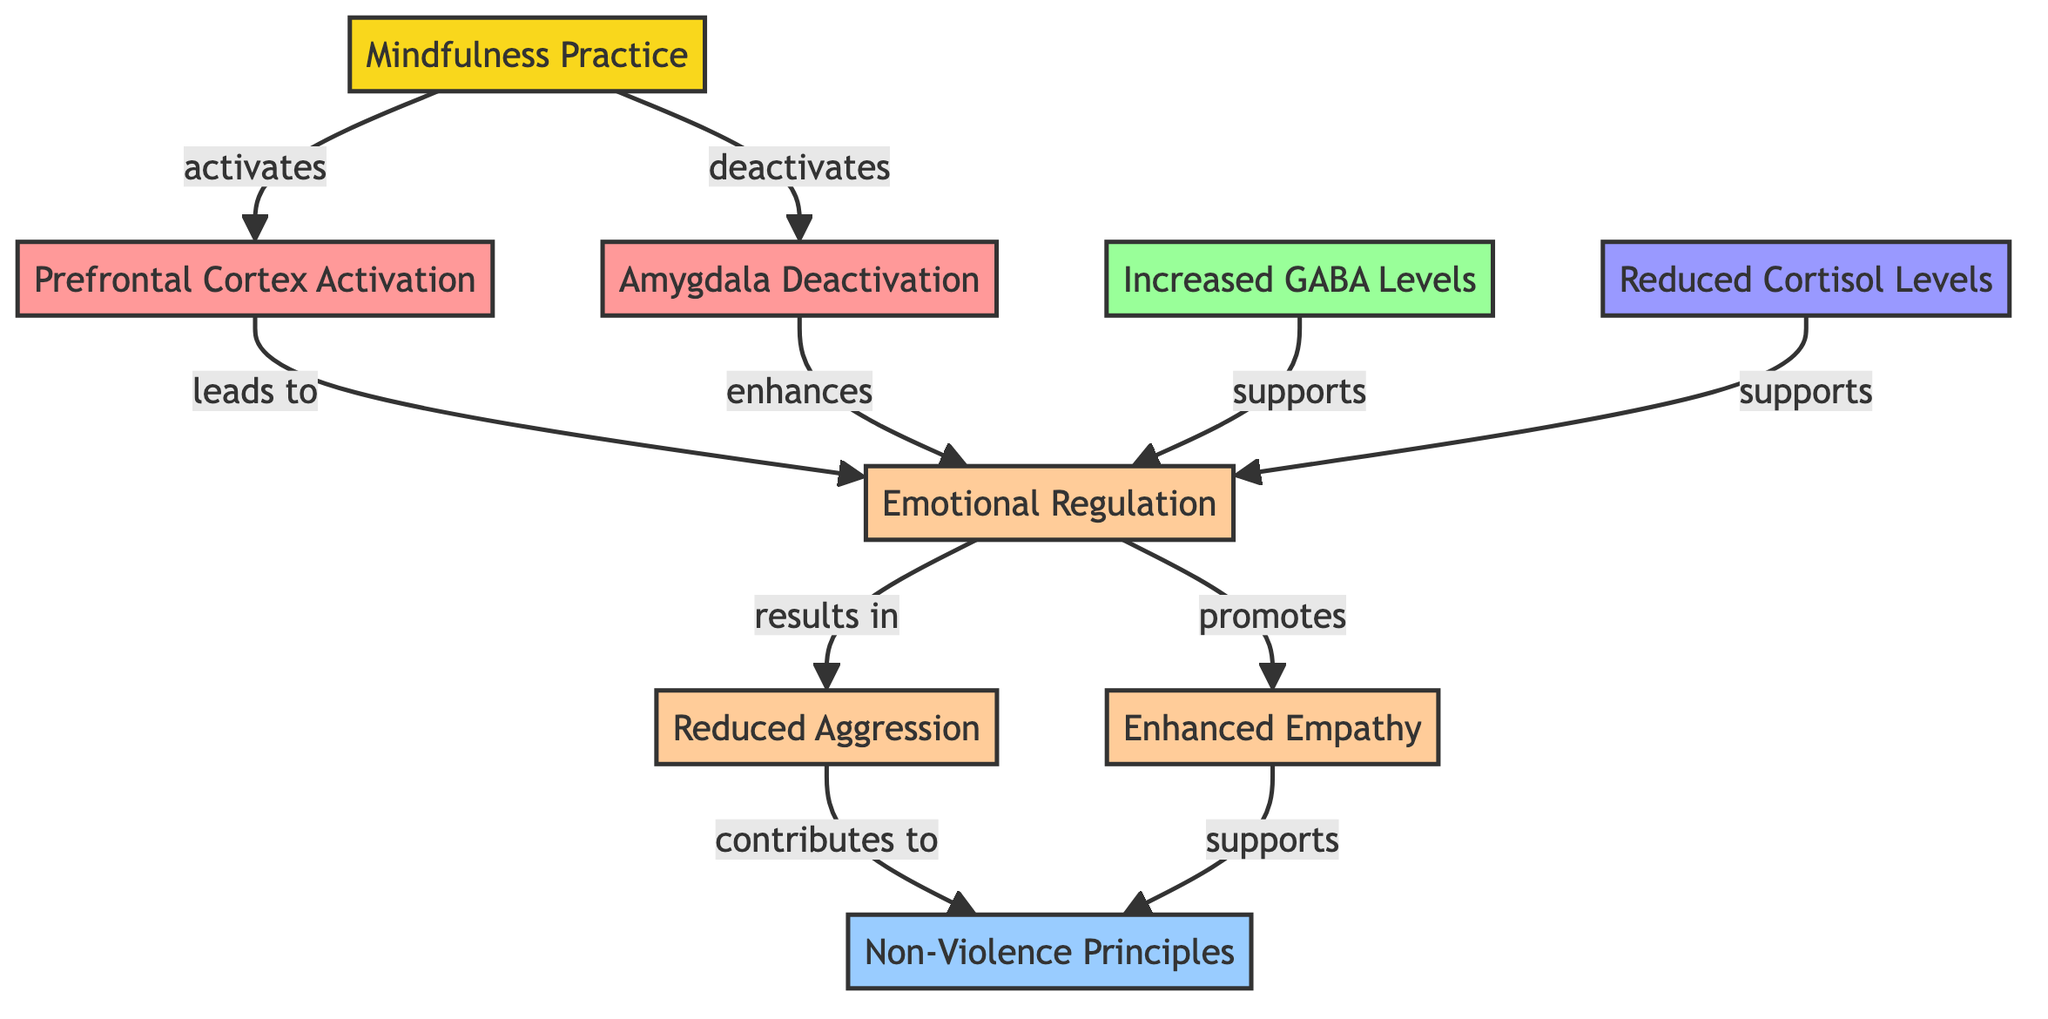What is the initial node in the diagram? The diagram begins with the node labeled "Mindfulness Practice." This is the first step that triggers the physiological changes in the brain.
Answer: Mindfulness Practice How many brain regions are identified in the diagram? There are two brain regions labeled in the diagram: the Prefrontal Cortex and the Amygdala. These nodes represent areas impacted by mindfulness practices.
Answer: 2 Which neurotransmitter level increases due to mindfulness? The diagram indicates that "Increased GABA Levels" is one of the neurotransmitter changes associated with mindfulness.
Answer: Increased GABA Levels What effect does the activation of the Prefrontal Cortex lead to? The activation of the Prefrontal Cortex is shown to lead to "Emotional Regulation," which is a crucial effect stemming from its stimulation.
Answer: Emotional Regulation How does reduced aggression relate to non-violence principles? Reduced aggression is depicted as a result derived from emotional regulation, which promotes non-violence principles. The diagram illustrates how these concepts are interconnected.
Answer: Contributes to What hormone levels are reduced as part of the physiological changes? The diagram identifies "Reduced Cortisol Levels" as the hormone impacted by mindfulness practice, indicating a stress-related change.
Answer: Reduced Cortisol Levels Which effect is promoted by enhanced empathy? Enhanced empathy supports the overarching outcome of "Non-Violence Principles," showing how it aligns with non-violent behaviors and thoughts.
Answer: Supports What role does amygdala deactivation play in emotional regulation? The amygdala's deactivation enhances emotional regulation in the diagram, meaning that a calmer and more stable emotional state is achieved through mindfulness practices.
Answer: Enhances How do mindfulness practices overall affect the brain? Overall, mindfulness practices activate specific brain regions, increase neurotransmitter levels, reduce stress hormones, and create effects like emotional regulation and empathy, leading to non-violent outcomes.
Answer: Activates specific regions, increases neurotransmitters, reduces stress 